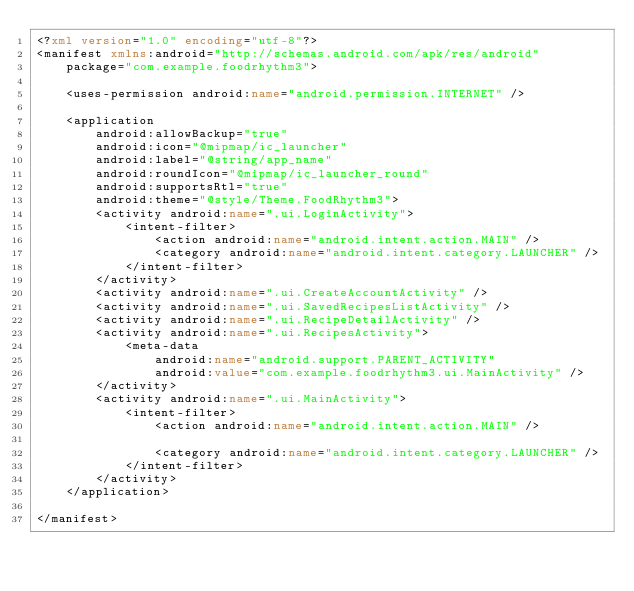<code> <loc_0><loc_0><loc_500><loc_500><_XML_><?xml version="1.0" encoding="utf-8"?>
<manifest xmlns:android="http://schemas.android.com/apk/res/android"
    package="com.example.foodrhythm3">

    <uses-permission android:name="android.permission.INTERNET" />

    <application
        android:allowBackup="true"
        android:icon="@mipmap/ic_launcher"
        android:label="@string/app_name"
        android:roundIcon="@mipmap/ic_launcher_round"
        android:supportsRtl="true"
        android:theme="@style/Theme.FoodRhythm3">
        <activity android:name=".ui.LoginActivity">
            <intent-filter>
                <action android:name="android.intent.action.MAIN" />
                <category android:name="android.intent.category.LAUNCHER" />
            </intent-filter>
        </activity>
        <activity android:name=".ui.CreateAccountActivity" />
        <activity android:name=".ui.SavedRecipesListActivity" />
        <activity android:name=".ui.RecipeDetailActivity" />
        <activity android:name=".ui.RecipesActivity">
            <meta-data
                android:name="android.support.PARENT_ACTIVITY"
                android:value="com.example.foodrhythm3.ui.MainActivity" />
        </activity>
        <activity android:name=".ui.MainActivity">
            <intent-filter>
                <action android:name="android.intent.action.MAIN" />

                <category android:name="android.intent.category.LAUNCHER" />
            </intent-filter>
        </activity>
    </application>

</manifest></code> 